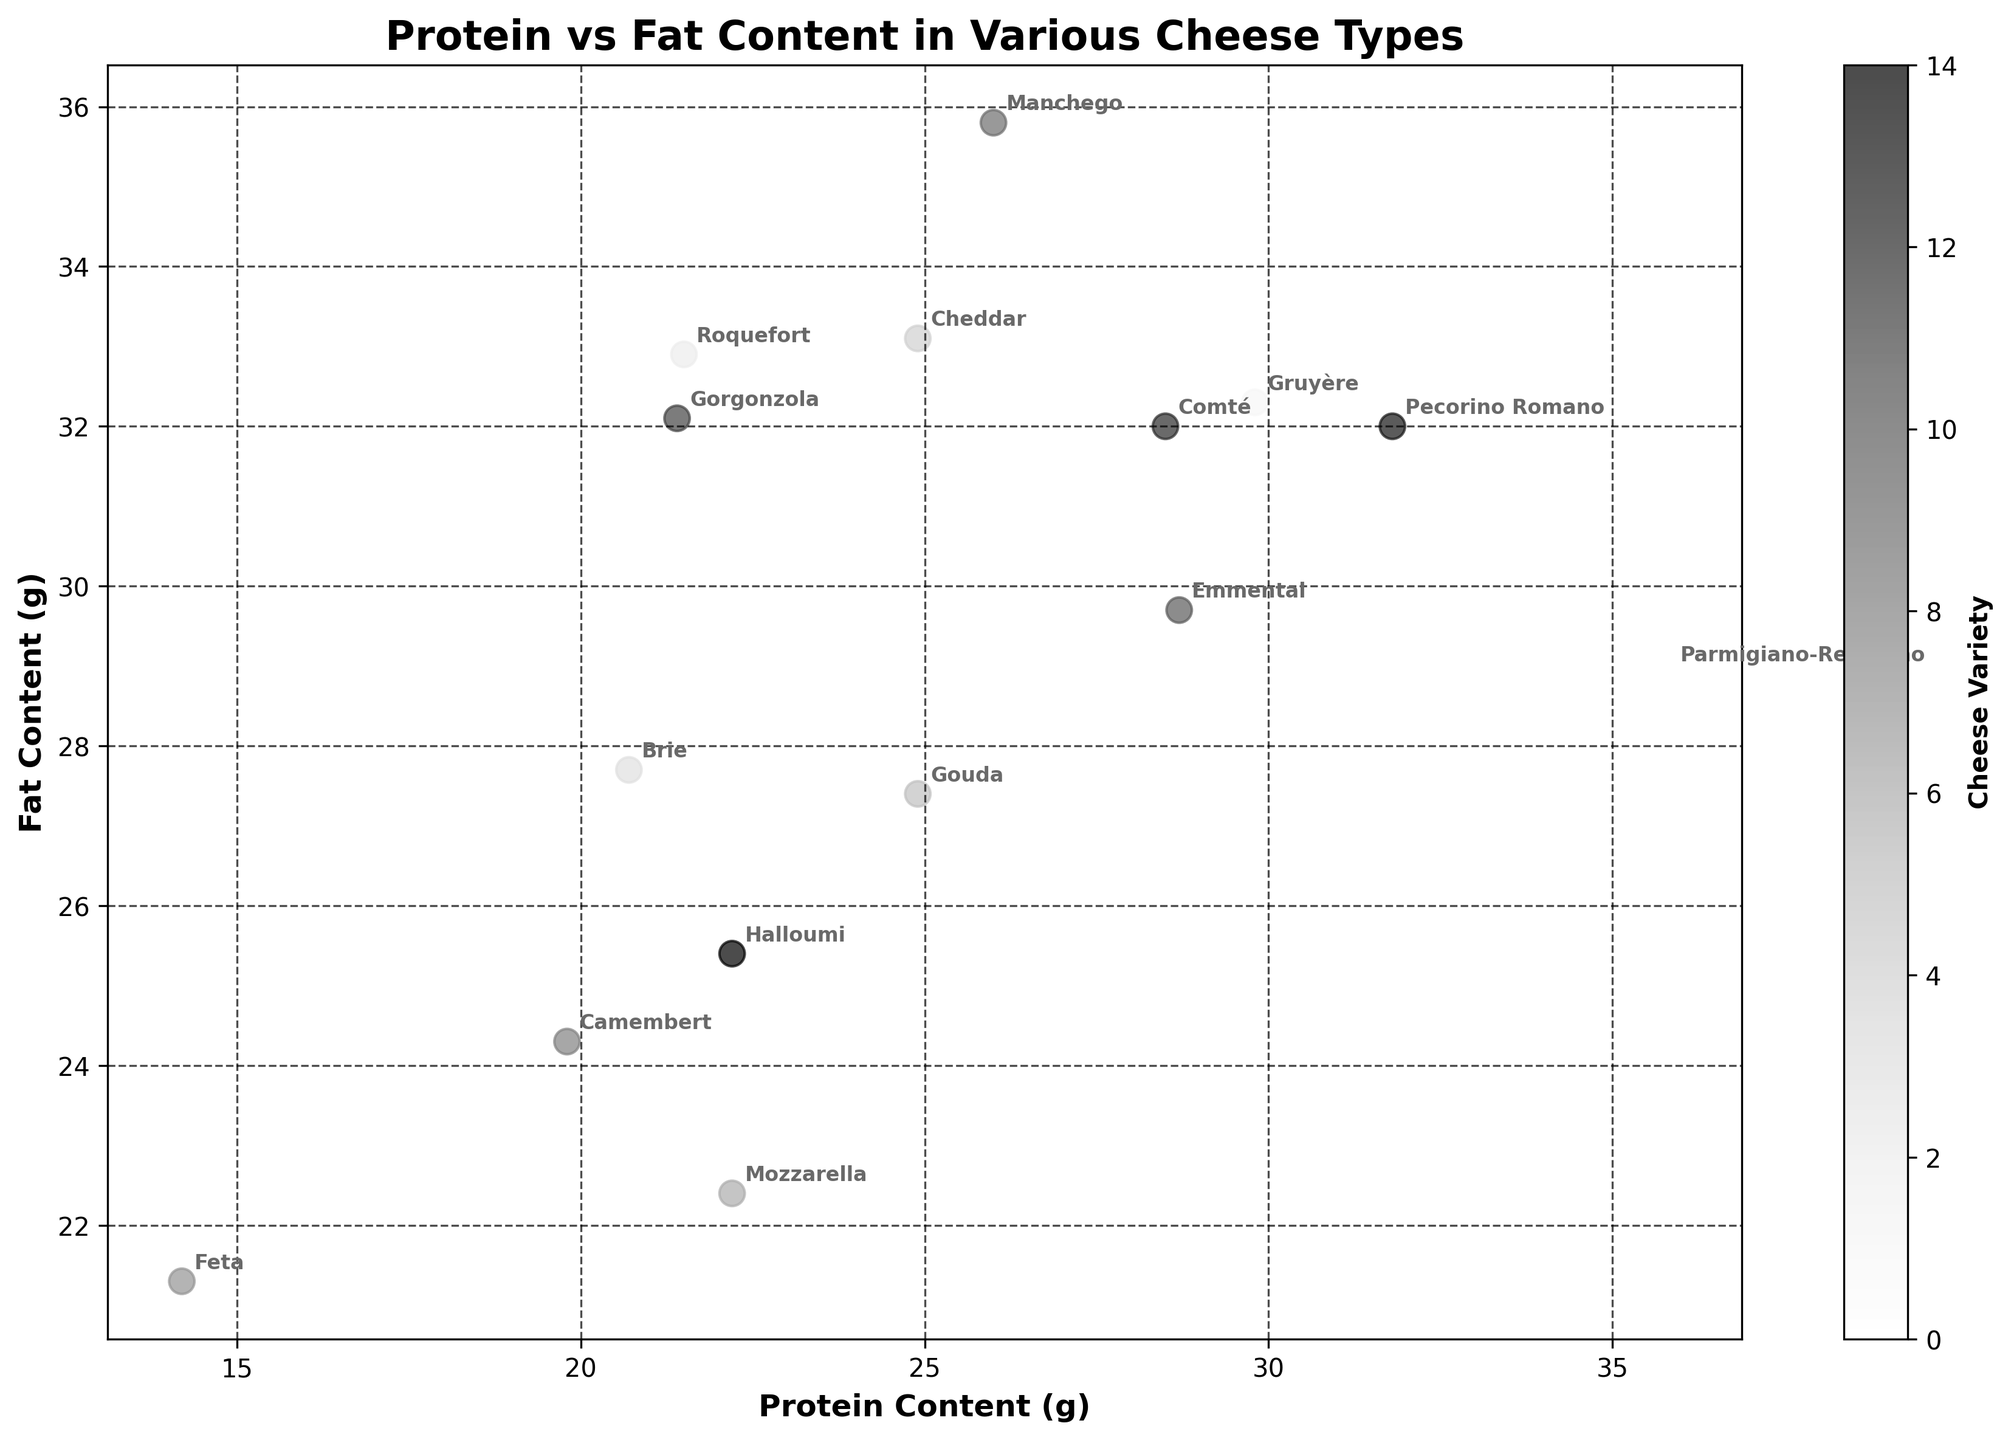What is the title of the figure? Look at the top of the figure where the title is usually placed. It reads "Protein vs Fat Content in Various Cheese Types".
Answer: Protein vs Fat Content in Various Cheese Types How many cheese types are shown in the figure? Count the number of points or labels on the scatter plot. Each point represents a cheese type. There are 15 data points in the plot.
Answer: 15 Which cheese has the highest protein content? Identify the point that is farthest to the right on the x-axis, as this axis represents protein content. Parmigiano-Reggiano lies farthest to the right with 35.8g of protein.
Answer: Parmigiano-Reggiano Which cheese has the highest fat content? Identify the point that is highest on the y-axis, as this axis represents fat content. Manchego lies highest with 35.8g of fat.
Answer: Manchego Which cheese has the lowest fat content? Locate the point that is lowest on the y-axis, indicating the lowest fat content. Feta is the lowest with 21.3g of fat.
Answer: Feta Are there any cheeses with equal protein and fat content? Look for any points that lie on the line y=x where protein equals fat. No points lie precisely on this line, suggesting there are no cheeses with equal protein and fat content.
Answer: No What is the average protein content across all cheeses? Sum all protein values and divide by the number of cheeses. The total protein content is 372.4g, and there are 15 cheeses: 372.4 / 15 gives an average protein content of approximately 24.83g.
Answer: 24.83g Which cheese has the closest protein content to Brie? Identify Brie's protein content (20.7g) and find the cheese with the closest x-coordinate. Camembert at 19.8g is the closest to Brie.
Answer: Camembert Which cheeses have a fat content greater than 32g? Identify points higher than 32 on the y-axis. Manchego, Roquefort, Cheddar, Comté, and Pecorino Romano all have fat content over 32g.
Answer: Manchego, Roquefort, Cheddar, Comté, Pecorino Romano Which cheese is placed closest to the origin (0,0)? Find the cheese with the smallest combined protein and fat values. Feta has the lowest combination with protein=14.2g and fat=21.3g, closest to (0,0).
Answer: Feta 